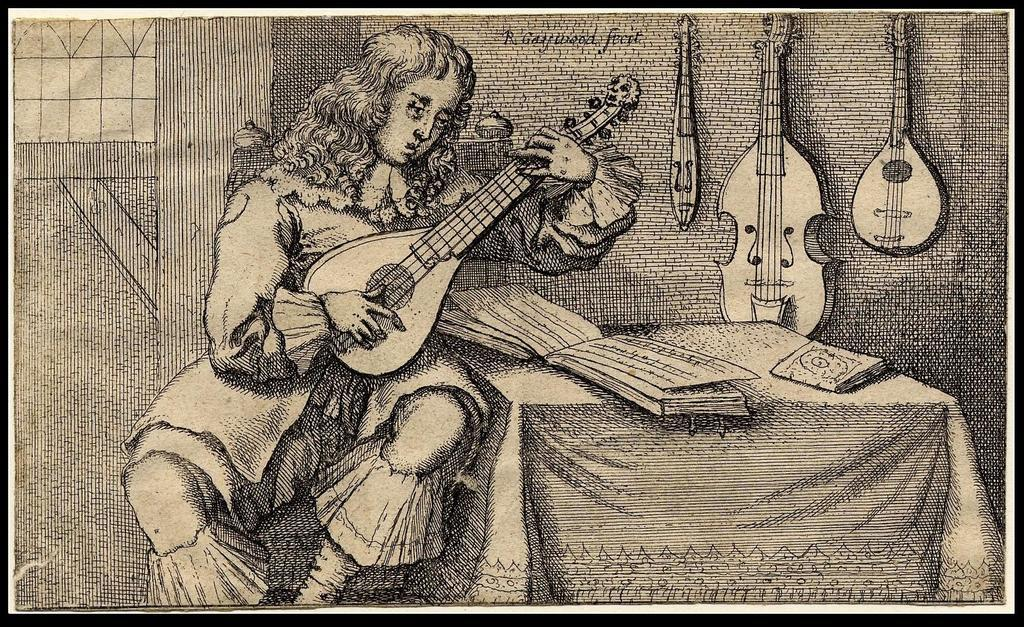What is the man in the image doing? The man is playing a guitar in the image. What object can be seen in the image besides the man and his guitar? There is a table in the image. What is on the table in the image? Books are placed on the table. What is visible on the wall in the image? Musical instruments are placed on the wall. Can you see any deer or goats in the image? No, there are no deer or goats present in the image. 